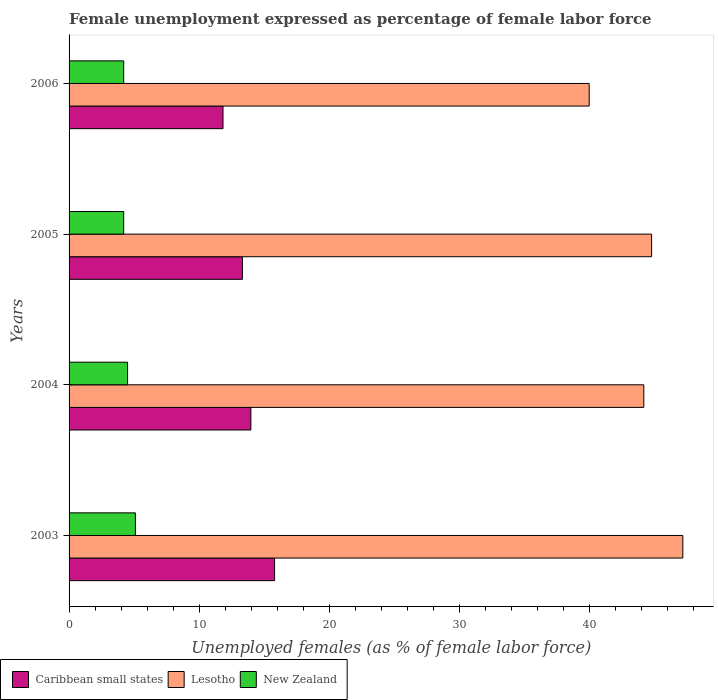How many different coloured bars are there?
Offer a terse response. 3. Are the number of bars per tick equal to the number of legend labels?
Offer a very short reply. Yes. How many bars are there on the 3rd tick from the bottom?
Give a very brief answer. 3. What is the label of the 4th group of bars from the top?
Make the answer very short. 2003. What is the unemployment in females in in New Zealand in 2003?
Make the answer very short. 5.1. Across all years, what is the maximum unemployment in females in in Lesotho?
Provide a short and direct response. 47.2. Across all years, what is the minimum unemployment in females in in Caribbean small states?
Provide a succinct answer. 11.84. What is the total unemployment in females in in New Zealand in the graph?
Offer a very short reply. 18. What is the difference between the unemployment in females in in New Zealand in 2004 and that in 2006?
Keep it short and to the point. 0.3. What is the difference between the unemployment in females in in Caribbean small states in 2004 and the unemployment in females in in Lesotho in 2003?
Provide a short and direct response. -33.22. What is the average unemployment in females in in Lesotho per year?
Provide a short and direct response. 44.05. In the year 2004, what is the difference between the unemployment in females in in Caribbean small states and unemployment in females in in Lesotho?
Provide a succinct answer. -30.22. What is the ratio of the unemployment in females in in Caribbean small states in 2004 to that in 2006?
Offer a very short reply. 1.18. Is the difference between the unemployment in females in in Caribbean small states in 2004 and 2005 greater than the difference between the unemployment in females in in Lesotho in 2004 and 2005?
Your answer should be compact. Yes. What is the difference between the highest and the second highest unemployment in females in in Caribbean small states?
Offer a terse response. 1.82. What is the difference between the highest and the lowest unemployment in females in in New Zealand?
Make the answer very short. 0.9. Is the sum of the unemployment in females in in Lesotho in 2004 and 2006 greater than the maximum unemployment in females in in Caribbean small states across all years?
Provide a succinct answer. Yes. What does the 3rd bar from the top in 2005 represents?
Offer a terse response. Caribbean small states. What does the 1st bar from the bottom in 2004 represents?
Offer a very short reply. Caribbean small states. Is it the case that in every year, the sum of the unemployment in females in in Lesotho and unemployment in females in in New Zealand is greater than the unemployment in females in in Caribbean small states?
Offer a terse response. Yes. How many bars are there?
Offer a very short reply. 12. How many years are there in the graph?
Your answer should be compact. 4. What is the difference between two consecutive major ticks on the X-axis?
Provide a succinct answer. 10. Are the values on the major ticks of X-axis written in scientific E-notation?
Ensure brevity in your answer.  No. Does the graph contain any zero values?
Offer a very short reply. No. Does the graph contain grids?
Provide a short and direct response. No. Where does the legend appear in the graph?
Make the answer very short. Bottom left. How are the legend labels stacked?
Give a very brief answer. Horizontal. What is the title of the graph?
Offer a very short reply. Female unemployment expressed as percentage of female labor force. Does "Tuvalu" appear as one of the legend labels in the graph?
Offer a terse response. No. What is the label or title of the X-axis?
Provide a short and direct response. Unemployed females (as % of female labor force). What is the label or title of the Y-axis?
Offer a terse response. Years. What is the Unemployed females (as % of female labor force) in Caribbean small states in 2003?
Make the answer very short. 15.81. What is the Unemployed females (as % of female labor force) of Lesotho in 2003?
Offer a terse response. 47.2. What is the Unemployed females (as % of female labor force) of New Zealand in 2003?
Give a very brief answer. 5.1. What is the Unemployed females (as % of female labor force) in Caribbean small states in 2004?
Your answer should be very brief. 13.98. What is the Unemployed females (as % of female labor force) in Lesotho in 2004?
Offer a very short reply. 44.2. What is the Unemployed females (as % of female labor force) of New Zealand in 2004?
Provide a succinct answer. 4.5. What is the Unemployed females (as % of female labor force) in Caribbean small states in 2005?
Provide a succinct answer. 13.33. What is the Unemployed females (as % of female labor force) of Lesotho in 2005?
Make the answer very short. 44.8. What is the Unemployed females (as % of female labor force) in New Zealand in 2005?
Your answer should be compact. 4.2. What is the Unemployed females (as % of female labor force) in Caribbean small states in 2006?
Keep it short and to the point. 11.84. What is the Unemployed females (as % of female labor force) of Lesotho in 2006?
Offer a terse response. 40. What is the Unemployed females (as % of female labor force) of New Zealand in 2006?
Offer a very short reply. 4.2. Across all years, what is the maximum Unemployed females (as % of female labor force) of Caribbean small states?
Offer a very short reply. 15.81. Across all years, what is the maximum Unemployed females (as % of female labor force) of Lesotho?
Provide a short and direct response. 47.2. Across all years, what is the maximum Unemployed females (as % of female labor force) of New Zealand?
Your response must be concise. 5.1. Across all years, what is the minimum Unemployed females (as % of female labor force) in Caribbean small states?
Your response must be concise. 11.84. Across all years, what is the minimum Unemployed females (as % of female labor force) of New Zealand?
Provide a short and direct response. 4.2. What is the total Unemployed females (as % of female labor force) in Caribbean small states in the graph?
Your answer should be very brief. 54.96. What is the total Unemployed females (as % of female labor force) of Lesotho in the graph?
Ensure brevity in your answer.  176.2. What is the total Unemployed females (as % of female labor force) of New Zealand in the graph?
Keep it short and to the point. 18. What is the difference between the Unemployed females (as % of female labor force) in Caribbean small states in 2003 and that in 2004?
Ensure brevity in your answer.  1.82. What is the difference between the Unemployed females (as % of female labor force) in Lesotho in 2003 and that in 2004?
Offer a terse response. 3. What is the difference between the Unemployed females (as % of female labor force) of Caribbean small states in 2003 and that in 2005?
Give a very brief answer. 2.47. What is the difference between the Unemployed females (as % of female labor force) of Lesotho in 2003 and that in 2005?
Make the answer very short. 2.4. What is the difference between the Unemployed females (as % of female labor force) of New Zealand in 2003 and that in 2005?
Your response must be concise. 0.9. What is the difference between the Unemployed females (as % of female labor force) in Caribbean small states in 2003 and that in 2006?
Keep it short and to the point. 3.97. What is the difference between the Unemployed females (as % of female labor force) of Caribbean small states in 2004 and that in 2005?
Your answer should be very brief. 0.65. What is the difference between the Unemployed females (as % of female labor force) of New Zealand in 2004 and that in 2005?
Your answer should be compact. 0.3. What is the difference between the Unemployed females (as % of female labor force) of Caribbean small states in 2004 and that in 2006?
Keep it short and to the point. 2.14. What is the difference between the Unemployed females (as % of female labor force) in Lesotho in 2004 and that in 2006?
Your answer should be very brief. 4.2. What is the difference between the Unemployed females (as % of female labor force) in New Zealand in 2004 and that in 2006?
Your answer should be compact. 0.3. What is the difference between the Unemployed females (as % of female labor force) in Caribbean small states in 2005 and that in 2006?
Offer a terse response. 1.49. What is the difference between the Unemployed females (as % of female labor force) of Lesotho in 2005 and that in 2006?
Offer a terse response. 4.8. What is the difference between the Unemployed females (as % of female labor force) of New Zealand in 2005 and that in 2006?
Your answer should be very brief. 0. What is the difference between the Unemployed females (as % of female labor force) of Caribbean small states in 2003 and the Unemployed females (as % of female labor force) of Lesotho in 2004?
Your answer should be very brief. -28.39. What is the difference between the Unemployed females (as % of female labor force) of Caribbean small states in 2003 and the Unemployed females (as % of female labor force) of New Zealand in 2004?
Give a very brief answer. 11.31. What is the difference between the Unemployed females (as % of female labor force) of Lesotho in 2003 and the Unemployed females (as % of female labor force) of New Zealand in 2004?
Give a very brief answer. 42.7. What is the difference between the Unemployed females (as % of female labor force) of Caribbean small states in 2003 and the Unemployed females (as % of female labor force) of Lesotho in 2005?
Provide a succinct answer. -28.99. What is the difference between the Unemployed females (as % of female labor force) in Caribbean small states in 2003 and the Unemployed females (as % of female labor force) in New Zealand in 2005?
Provide a short and direct response. 11.61. What is the difference between the Unemployed females (as % of female labor force) of Caribbean small states in 2003 and the Unemployed females (as % of female labor force) of Lesotho in 2006?
Provide a short and direct response. -24.19. What is the difference between the Unemployed females (as % of female labor force) of Caribbean small states in 2003 and the Unemployed females (as % of female labor force) of New Zealand in 2006?
Keep it short and to the point. 11.61. What is the difference between the Unemployed females (as % of female labor force) in Lesotho in 2003 and the Unemployed females (as % of female labor force) in New Zealand in 2006?
Provide a short and direct response. 43. What is the difference between the Unemployed females (as % of female labor force) of Caribbean small states in 2004 and the Unemployed females (as % of female labor force) of Lesotho in 2005?
Your answer should be very brief. -30.82. What is the difference between the Unemployed females (as % of female labor force) in Caribbean small states in 2004 and the Unemployed females (as % of female labor force) in New Zealand in 2005?
Make the answer very short. 9.78. What is the difference between the Unemployed females (as % of female labor force) of Lesotho in 2004 and the Unemployed females (as % of female labor force) of New Zealand in 2005?
Provide a short and direct response. 40. What is the difference between the Unemployed females (as % of female labor force) in Caribbean small states in 2004 and the Unemployed females (as % of female labor force) in Lesotho in 2006?
Offer a very short reply. -26.02. What is the difference between the Unemployed females (as % of female labor force) of Caribbean small states in 2004 and the Unemployed females (as % of female labor force) of New Zealand in 2006?
Offer a terse response. 9.78. What is the difference between the Unemployed females (as % of female labor force) of Caribbean small states in 2005 and the Unemployed females (as % of female labor force) of Lesotho in 2006?
Your answer should be compact. -26.67. What is the difference between the Unemployed females (as % of female labor force) in Caribbean small states in 2005 and the Unemployed females (as % of female labor force) in New Zealand in 2006?
Offer a terse response. 9.13. What is the difference between the Unemployed females (as % of female labor force) in Lesotho in 2005 and the Unemployed females (as % of female labor force) in New Zealand in 2006?
Your answer should be very brief. 40.6. What is the average Unemployed females (as % of female labor force) of Caribbean small states per year?
Your answer should be very brief. 13.74. What is the average Unemployed females (as % of female labor force) of Lesotho per year?
Provide a succinct answer. 44.05. What is the average Unemployed females (as % of female labor force) of New Zealand per year?
Ensure brevity in your answer.  4.5. In the year 2003, what is the difference between the Unemployed females (as % of female labor force) of Caribbean small states and Unemployed females (as % of female labor force) of Lesotho?
Your response must be concise. -31.39. In the year 2003, what is the difference between the Unemployed females (as % of female labor force) in Caribbean small states and Unemployed females (as % of female labor force) in New Zealand?
Your answer should be very brief. 10.71. In the year 2003, what is the difference between the Unemployed females (as % of female labor force) of Lesotho and Unemployed females (as % of female labor force) of New Zealand?
Make the answer very short. 42.1. In the year 2004, what is the difference between the Unemployed females (as % of female labor force) in Caribbean small states and Unemployed females (as % of female labor force) in Lesotho?
Offer a very short reply. -30.22. In the year 2004, what is the difference between the Unemployed females (as % of female labor force) of Caribbean small states and Unemployed females (as % of female labor force) of New Zealand?
Ensure brevity in your answer.  9.48. In the year 2004, what is the difference between the Unemployed females (as % of female labor force) of Lesotho and Unemployed females (as % of female labor force) of New Zealand?
Provide a succinct answer. 39.7. In the year 2005, what is the difference between the Unemployed females (as % of female labor force) in Caribbean small states and Unemployed females (as % of female labor force) in Lesotho?
Keep it short and to the point. -31.47. In the year 2005, what is the difference between the Unemployed females (as % of female labor force) in Caribbean small states and Unemployed females (as % of female labor force) in New Zealand?
Offer a terse response. 9.13. In the year 2005, what is the difference between the Unemployed females (as % of female labor force) in Lesotho and Unemployed females (as % of female labor force) in New Zealand?
Offer a very short reply. 40.6. In the year 2006, what is the difference between the Unemployed females (as % of female labor force) of Caribbean small states and Unemployed females (as % of female labor force) of Lesotho?
Make the answer very short. -28.16. In the year 2006, what is the difference between the Unemployed females (as % of female labor force) in Caribbean small states and Unemployed females (as % of female labor force) in New Zealand?
Keep it short and to the point. 7.64. In the year 2006, what is the difference between the Unemployed females (as % of female labor force) in Lesotho and Unemployed females (as % of female labor force) in New Zealand?
Offer a very short reply. 35.8. What is the ratio of the Unemployed females (as % of female labor force) in Caribbean small states in 2003 to that in 2004?
Provide a succinct answer. 1.13. What is the ratio of the Unemployed females (as % of female labor force) of Lesotho in 2003 to that in 2004?
Offer a very short reply. 1.07. What is the ratio of the Unemployed females (as % of female labor force) in New Zealand in 2003 to that in 2004?
Offer a terse response. 1.13. What is the ratio of the Unemployed females (as % of female labor force) of Caribbean small states in 2003 to that in 2005?
Ensure brevity in your answer.  1.19. What is the ratio of the Unemployed females (as % of female labor force) of Lesotho in 2003 to that in 2005?
Offer a terse response. 1.05. What is the ratio of the Unemployed females (as % of female labor force) of New Zealand in 2003 to that in 2005?
Your response must be concise. 1.21. What is the ratio of the Unemployed females (as % of female labor force) in Caribbean small states in 2003 to that in 2006?
Keep it short and to the point. 1.34. What is the ratio of the Unemployed females (as % of female labor force) in Lesotho in 2003 to that in 2006?
Your response must be concise. 1.18. What is the ratio of the Unemployed females (as % of female labor force) in New Zealand in 2003 to that in 2006?
Your answer should be compact. 1.21. What is the ratio of the Unemployed females (as % of female labor force) in Caribbean small states in 2004 to that in 2005?
Make the answer very short. 1.05. What is the ratio of the Unemployed females (as % of female labor force) in Lesotho in 2004 to that in 2005?
Ensure brevity in your answer.  0.99. What is the ratio of the Unemployed females (as % of female labor force) of New Zealand in 2004 to that in 2005?
Your response must be concise. 1.07. What is the ratio of the Unemployed females (as % of female labor force) in Caribbean small states in 2004 to that in 2006?
Provide a succinct answer. 1.18. What is the ratio of the Unemployed females (as % of female labor force) of Lesotho in 2004 to that in 2006?
Ensure brevity in your answer.  1.1. What is the ratio of the Unemployed females (as % of female labor force) in New Zealand in 2004 to that in 2006?
Make the answer very short. 1.07. What is the ratio of the Unemployed females (as % of female labor force) of Caribbean small states in 2005 to that in 2006?
Your answer should be compact. 1.13. What is the ratio of the Unemployed females (as % of female labor force) in Lesotho in 2005 to that in 2006?
Offer a very short reply. 1.12. What is the difference between the highest and the second highest Unemployed females (as % of female labor force) of Caribbean small states?
Provide a succinct answer. 1.82. What is the difference between the highest and the second highest Unemployed females (as % of female labor force) in Lesotho?
Offer a very short reply. 2.4. What is the difference between the highest and the second highest Unemployed females (as % of female labor force) of New Zealand?
Your response must be concise. 0.6. What is the difference between the highest and the lowest Unemployed females (as % of female labor force) of Caribbean small states?
Offer a terse response. 3.97. 